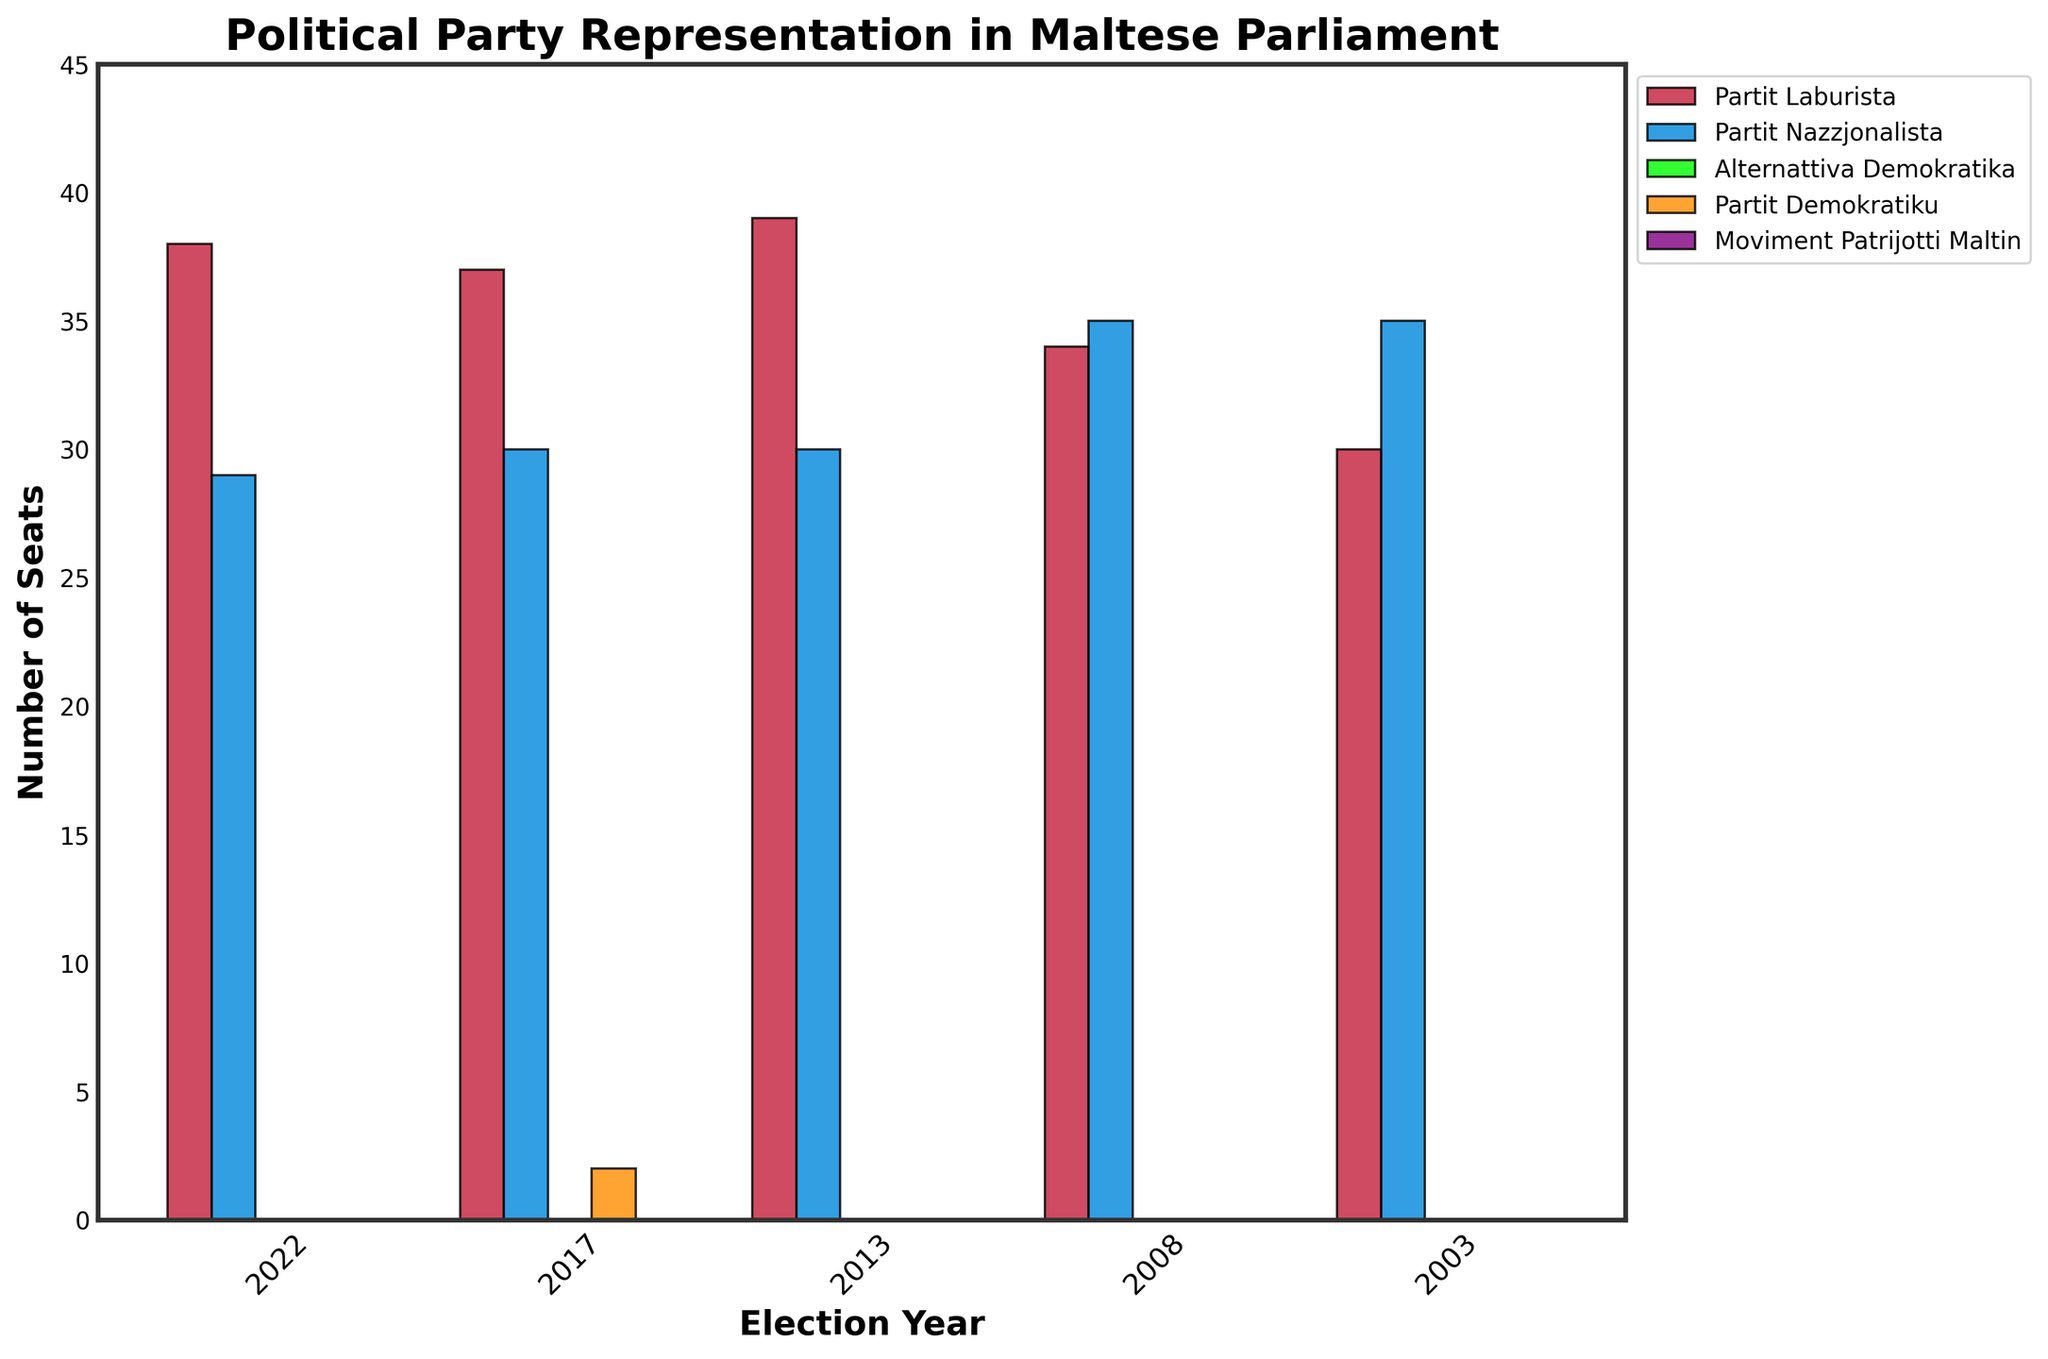What is the overall trend in the number of seats for Partit Laburista over the last five elections? To determine the trend, we look at the number of seats of Partit Laburista across the years 2003, 2008, 2013, 2017, and 2022 given in the chart: 30, 34, 39, 37, and 38. The number of seats initially increases from 30 to 39, drops slightly to 37, and then rises again to 38. The overall trend is an increase.
Answer: Increasing Which party had the highest number of seats in the 2008 election? By examining the 2008 election year on the chart, Partit Nazzjonalista had 35 seats, which is higher than the 34 seats of Partit Laburista. The other parties had zero seats. Therefore, Partit Nazzjonalista had the highest number of seats.
Answer: Partit Nazzjonalista How many more seats did Partit Laburista have compared to Partit Nazzjonalista in 2013? In 2013, Partit Laburista had 39 seats, and Partit Nazzjonalista had 30 seats. The difference between the seats is found by subtracting 30 from 39. So, the difference is 39 - 30 = 9 seats.
Answer: 9 seats In which election year did Partit Demokratiku gain seats, and how many did they gain? From the chart, Partit Demokratiku gained seats in the 2017 election. By reading off the chart for 2017, Partit Demokratiku had 2 seats.
Answer: 2017, 2 seats Which party had a consistent representation of zero seats over the five elections? From the chart, both Alternattiva Demokratika and Moviment Patrijotti Maltin had consistently zero seats over the election years 2003, 2008, 2013, 2017, and 2022.
Answer: Alternattiva Demokratika and Moviment Patrijotti Maltin For how many election years did Partit Nazzjonalista have more seats than Partit Laburista? By comparing the seats of Partit Laburista and Partit Nazzjonalista for each election year: 2003, 2008, 2013, 2017, and 2022, we see that in 2003 and 2008 Partit Nazzjonalista had more seats. Therefore, there were 2 such election years.
Answer: 2 years What is the average number of seats obtained by Partit Laburista over the last five elections? To find the average, add the total number of seats obtained by Partit Laburista across all five elections (30 + 34 + 39 + 37 + 38) and divide by the number of elections, which is 5: (30 + 34 + 39 + 37 + 38) / 5 = 178 / 5 = 35.6
Answer: 35.6 Between 2017 and 2022, how did the number of seats held by Partit Nazzjonalista change? In 2017, Partit Nazzjonalista held 30 seats, and in 2022, they held 29 seats. The number of seats decreased. The change in seats can be calculated by subtracting 29 from 30, which gives a decrease of 1 seat.
Answer: Decreased by 1 seat 